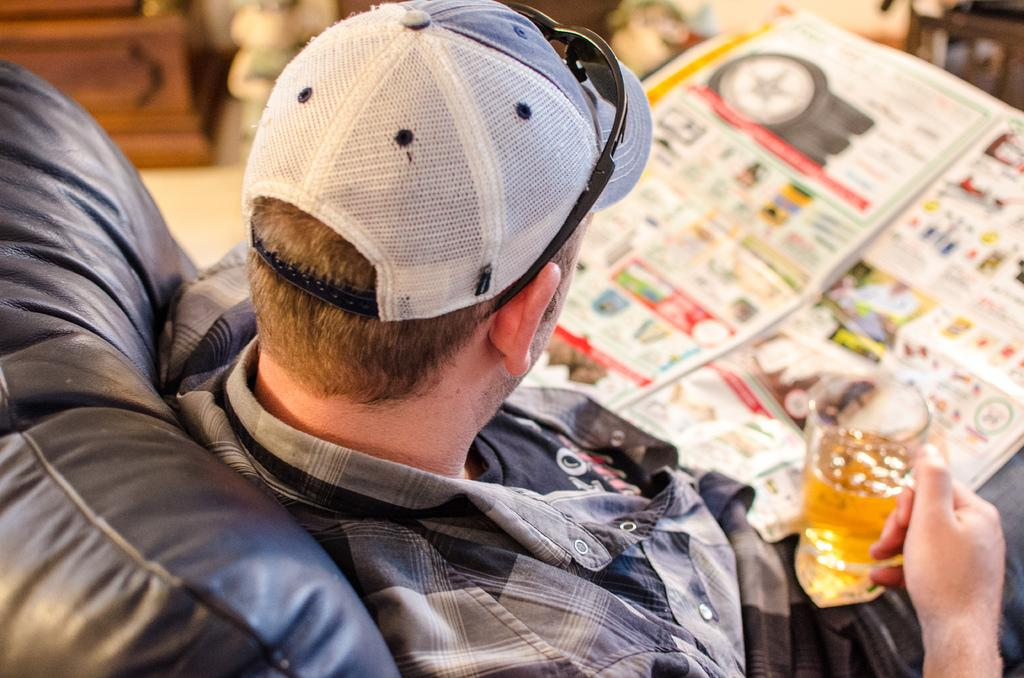Who is the person in the image? There is a man in the image. What is the man holding in his hand? The man is holding a beer in his hand. What activity is the man engaged in? The man is reading a newspaper. What is the man sitting on? The man is sitting on a chair. What object can be seen in the top left corner of the image? There is a desk in the top left corner of the image. What type of list is the man making in the image? There is no list present in the image; the man is holding a beer and reading a newspaper. 